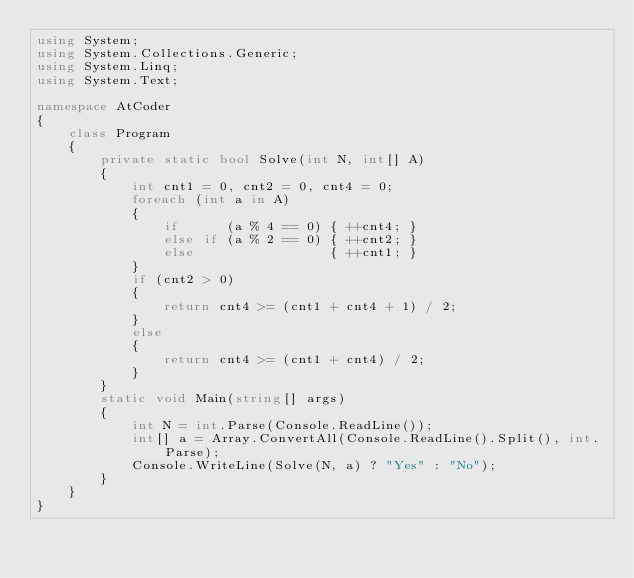<code> <loc_0><loc_0><loc_500><loc_500><_C#_>using System;
using System.Collections.Generic;
using System.Linq;
using System.Text;

namespace AtCoder
{
    class Program
    {
        private static bool Solve(int N, int[] A)
        {
            int cnt1 = 0, cnt2 = 0, cnt4 = 0;
            foreach (int a in A)
            {
                if      (a % 4 == 0) { ++cnt4; }
                else if (a % 2 == 0) { ++cnt2; }
                else                 { ++cnt1; }
            }
            if (cnt2 > 0)
            {
                return cnt4 >= (cnt1 + cnt4 + 1) / 2;
            }
            else
            {
                return cnt4 >= (cnt1 + cnt4) / 2;
            }
        }
        static void Main(string[] args)
        {
            int N = int.Parse(Console.ReadLine());
            int[] a = Array.ConvertAll(Console.ReadLine().Split(), int.Parse);
            Console.WriteLine(Solve(N, a) ? "Yes" : "No");
        }
    }
}
</code> 